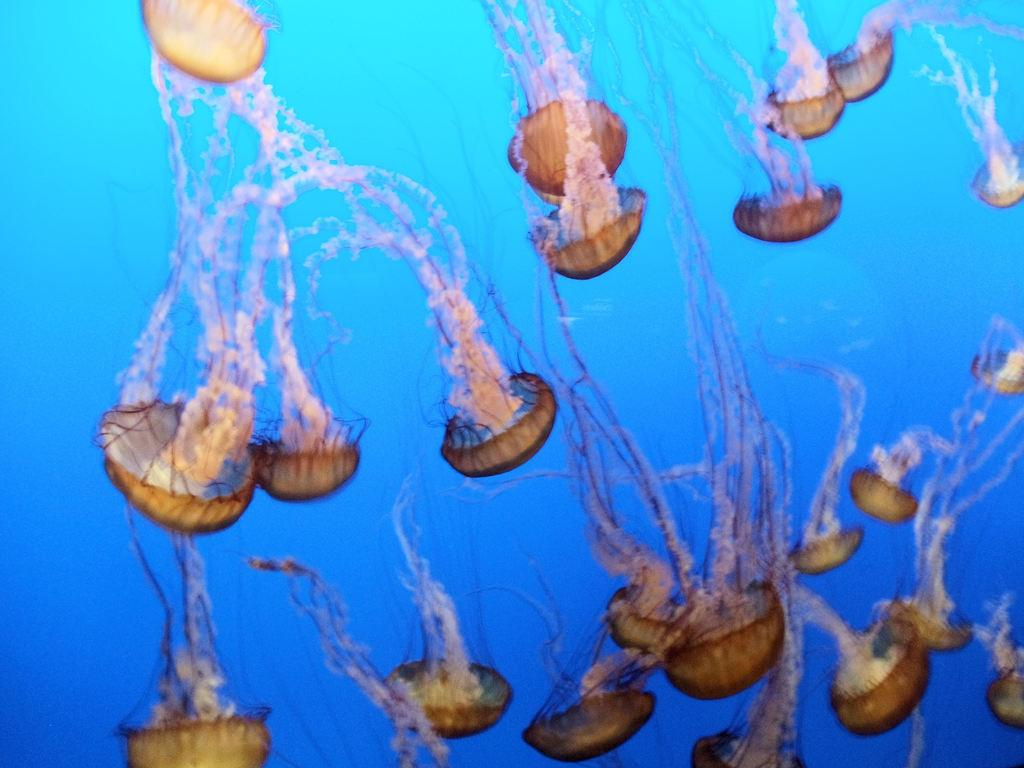What type of animals can be seen in the water in the image? There are jellyfishes in the water in the image. Can you describe the environment where the jellyfishes are located? The jellyfishes are located in the water. What type of destruction can be seen in the image caused by the jellyfishes? There is no destruction caused by the jellyfishes visible in the image. How many feet are visible in the image? There are no feet visible in the image, as it features jellyfishes in the water. 